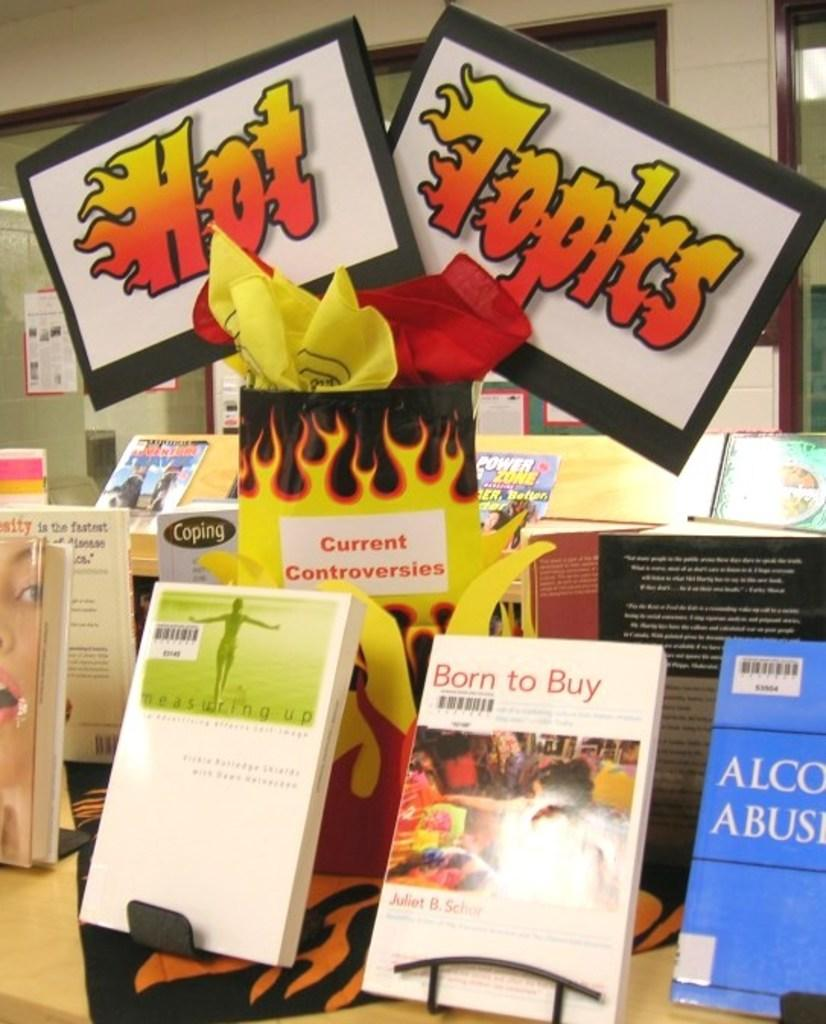<image>
Offer a succinct explanation of the picture presented. Books on the rack on Hot topics such as Born to buy, Current controversies etc. 